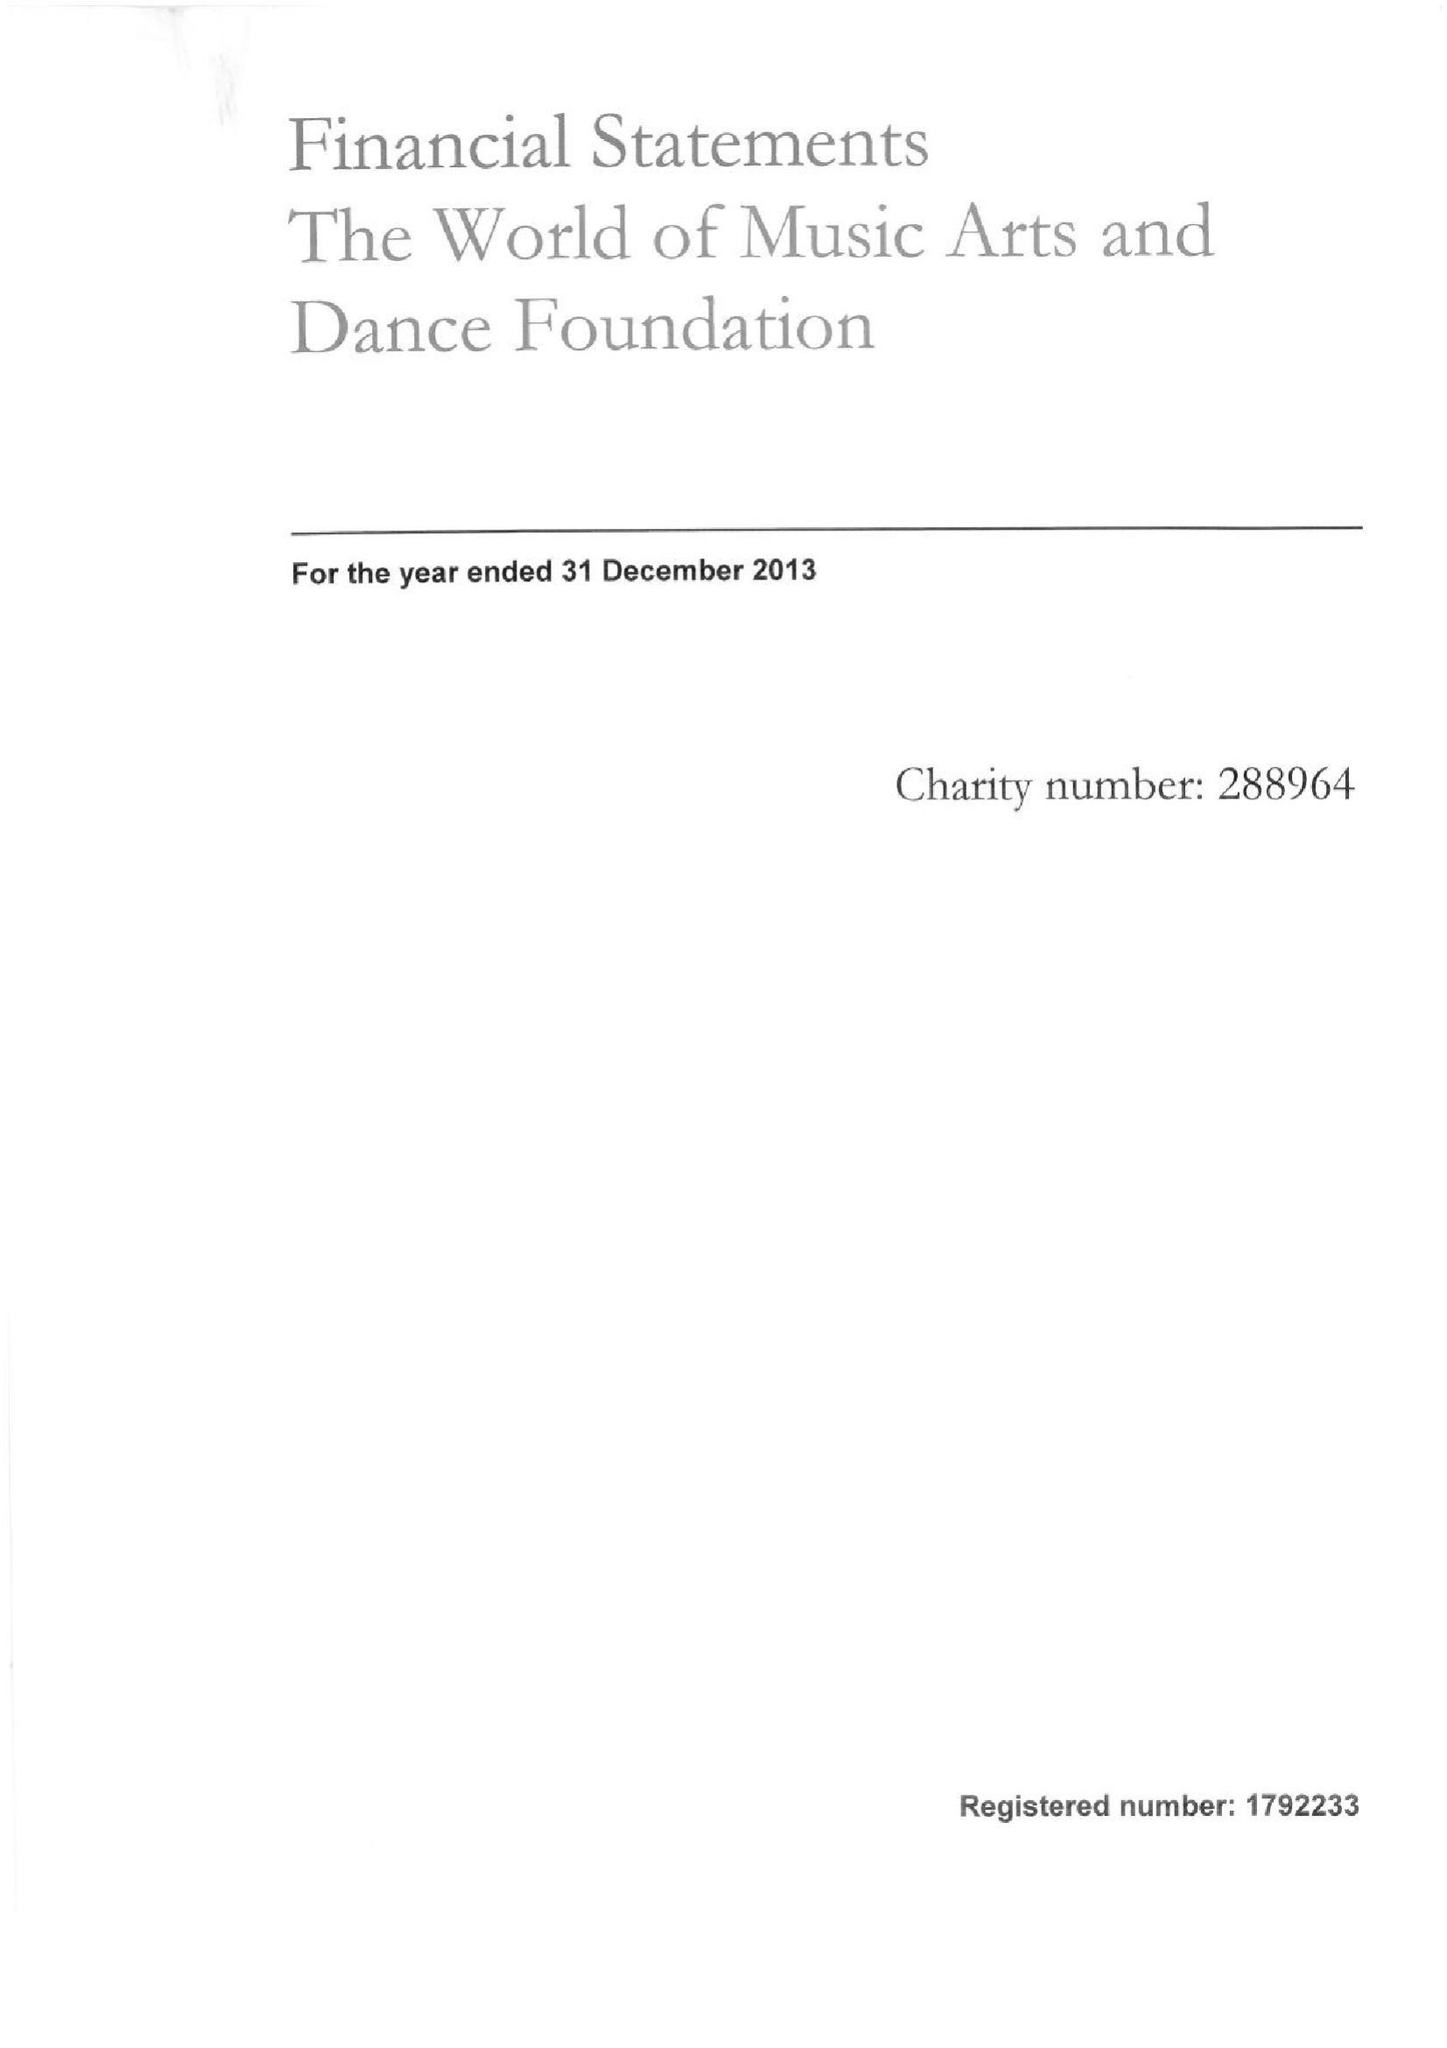What is the value for the spending_annually_in_british_pounds?
Answer the question using a single word or phrase. 99064.00 